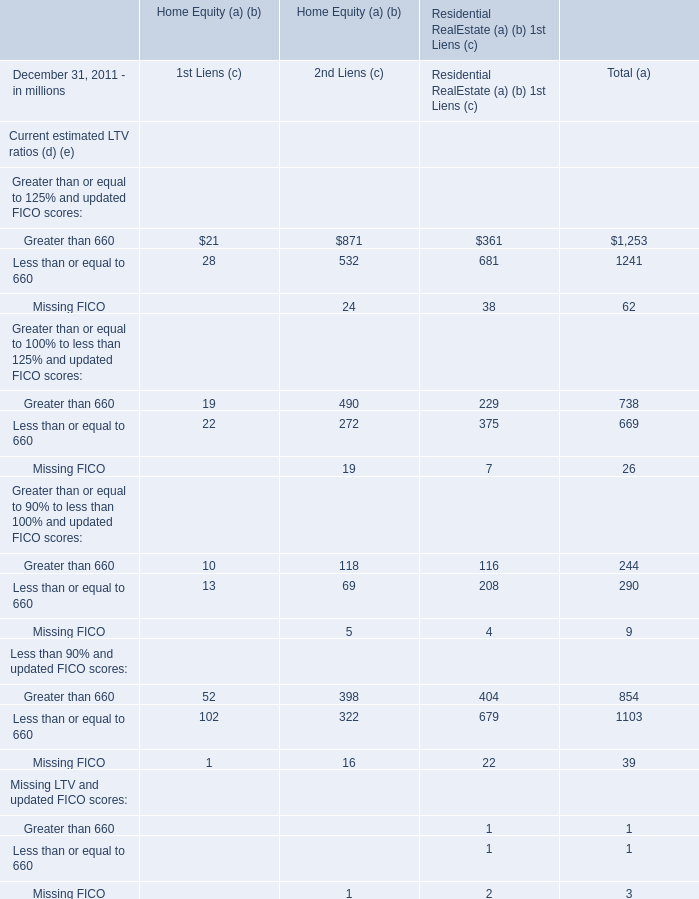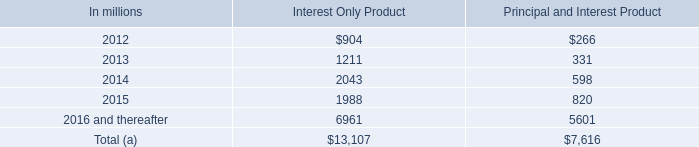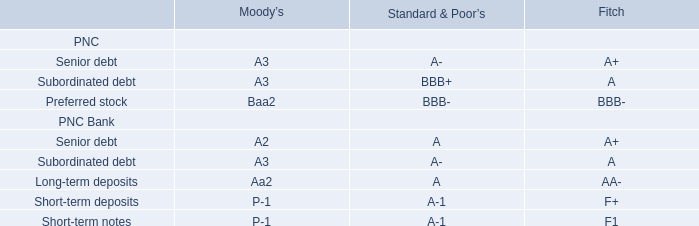what is the average , in millions , home equity line of credit with balloon payments with draw periods from 2012 to 2016? 
Computations: (((((306 + 44) + 60) + 100) + 246) / 5)
Answer: 151.2. 